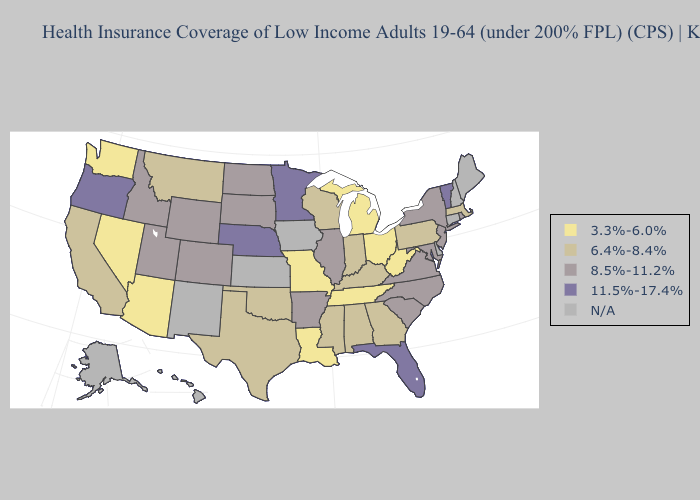What is the value of North Carolina?
Short answer required. 8.5%-11.2%. Among the states that border Wisconsin , does Illinois have the lowest value?
Quick response, please. No. Does Florida have the lowest value in the South?
Be succinct. No. Name the states that have a value in the range 11.5%-17.4%?
Concise answer only. Florida, Minnesota, Nebraska, Oregon, Vermont. Among the states that border Utah , does Colorado have the lowest value?
Be succinct. No. Name the states that have a value in the range 8.5%-11.2%?
Be succinct. Arkansas, Colorado, Idaho, Illinois, Maryland, New Jersey, New York, North Carolina, North Dakota, Rhode Island, South Carolina, South Dakota, Utah, Virginia, Wyoming. What is the value of Oregon?
Keep it brief. 11.5%-17.4%. Name the states that have a value in the range N/A?
Write a very short answer. Alaska, Connecticut, Delaware, Hawaii, Iowa, Kansas, Maine, New Hampshire, New Mexico. Name the states that have a value in the range 6.4%-8.4%?
Keep it brief. Alabama, California, Georgia, Indiana, Kentucky, Massachusetts, Mississippi, Montana, Oklahoma, Pennsylvania, Texas, Wisconsin. What is the value of Utah?
Answer briefly. 8.5%-11.2%. What is the highest value in the USA?
Give a very brief answer. 11.5%-17.4%. Does Vermont have the highest value in the USA?
Give a very brief answer. Yes. Name the states that have a value in the range N/A?
Concise answer only. Alaska, Connecticut, Delaware, Hawaii, Iowa, Kansas, Maine, New Hampshire, New Mexico. Does Arizona have the lowest value in the West?
Write a very short answer. Yes. 